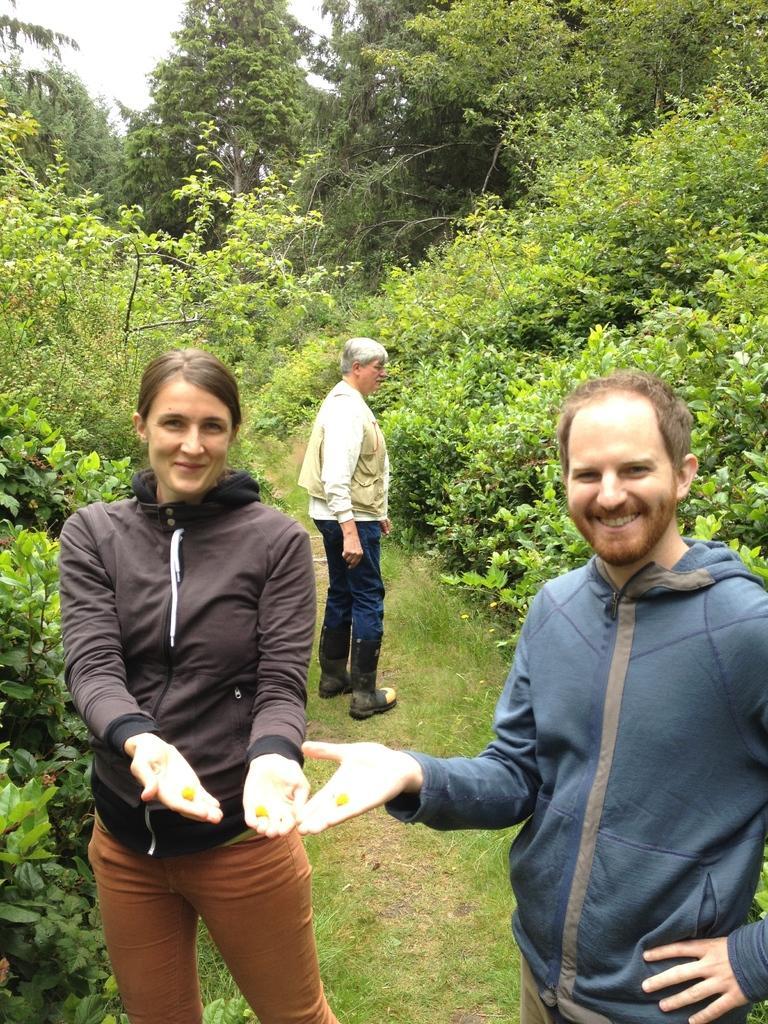In one or two sentences, can you explain what this image depicts? In this image we can see three persons standing on the ground, two of them are holding few objects in their hands and there are few trees and the sky in the background. 